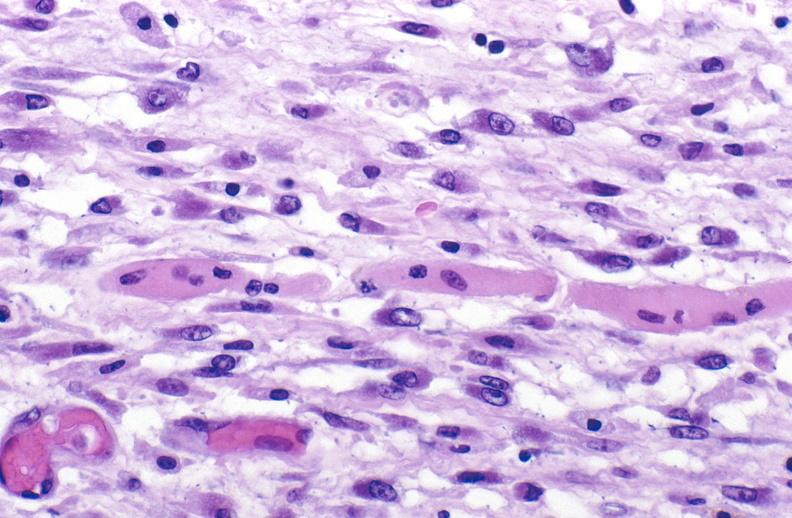s malignant histiocytosis present?
Answer the question using a single word or phrase. No 